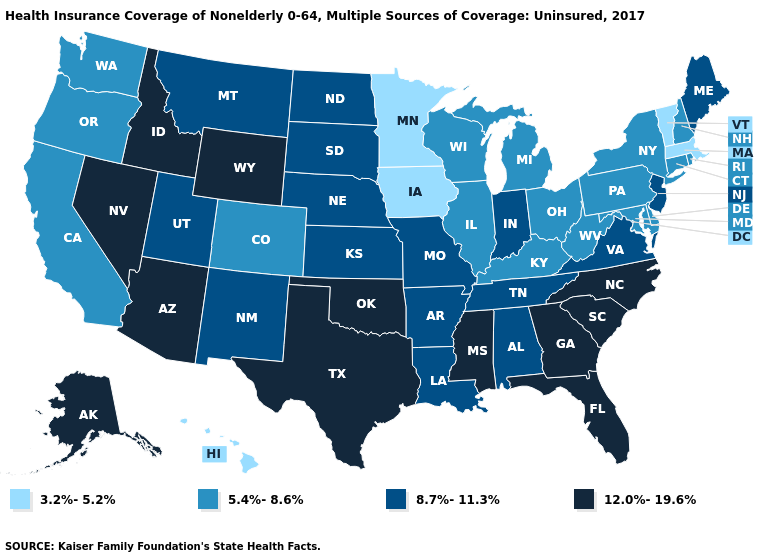Name the states that have a value in the range 12.0%-19.6%?
Concise answer only. Alaska, Arizona, Florida, Georgia, Idaho, Mississippi, Nevada, North Carolina, Oklahoma, South Carolina, Texas, Wyoming. Does Montana have a lower value than Idaho?
Be succinct. Yes. Name the states that have a value in the range 12.0%-19.6%?
Quick response, please. Alaska, Arizona, Florida, Georgia, Idaho, Mississippi, Nevada, North Carolina, Oklahoma, South Carolina, Texas, Wyoming. What is the value of Iowa?
Concise answer only. 3.2%-5.2%. Does Maine have a higher value than Virginia?
Short answer required. No. Name the states that have a value in the range 5.4%-8.6%?
Be succinct. California, Colorado, Connecticut, Delaware, Illinois, Kentucky, Maryland, Michigan, New Hampshire, New York, Ohio, Oregon, Pennsylvania, Rhode Island, Washington, West Virginia, Wisconsin. What is the value of Oregon?
Answer briefly. 5.4%-8.6%. What is the lowest value in the USA?
Short answer required. 3.2%-5.2%. Name the states that have a value in the range 5.4%-8.6%?
Short answer required. California, Colorado, Connecticut, Delaware, Illinois, Kentucky, Maryland, Michigan, New Hampshire, New York, Ohio, Oregon, Pennsylvania, Rhode Island, Washington, West Virginia, Wisconsin. Which states have the highest value in the USA?
Keep it brief. Alaska, Arizona, Florida, Georgia, Idaho, Mississippi, Nevada, North Carolina, Oklahoma, South Carolina, Texas, Wyoming. Name the states that have a value in the range 8.7%-11.3%?
Be succinct. Alabama, Arkansas, Indiana, Kansas, Louisiana, Maine, Missouri, Montana, Nebraska, New Jersey, New Mexico, North Dakota, South Dakota, Tennessee, Utah, Virginia. What is the value of Alabama?
Short answer required. 8.7%-11.3%. What is the value of Hawaii?
Quick response, please. 3.2%-5.2%. Is the legend a continuous bar?
Be succinct. No. Among the states that border Virginia , does North Carolina have the highest value?
Quick response, please. Yes. 